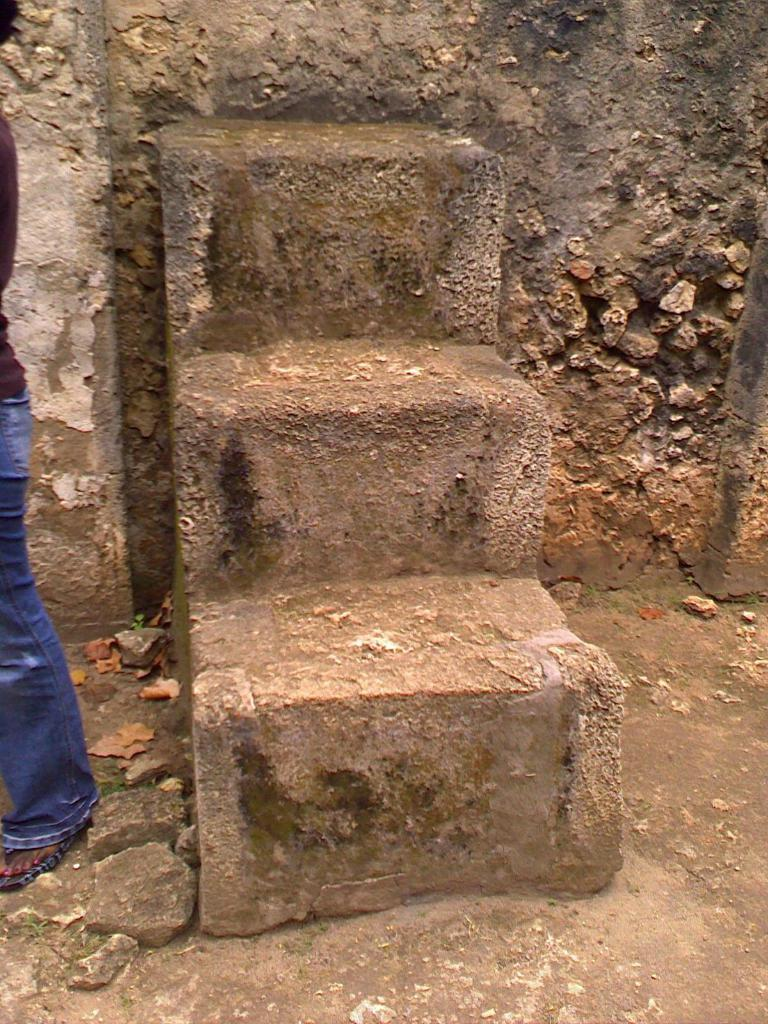How many steps are visible on the wall in the image? There are three steps on the wall in the image. Are the steps part of a larger structure or freestanding? The steps are attached to a wall. What can be seen on the left side of the image? There is a person on the left side of the image. What type of surface is present on the ground in the image? Small stones are present on the ground. How many cakes does the person on the left side of the image have? There is no mention of cakes in the image, so it is impossible to determine how many cakes the person has. 